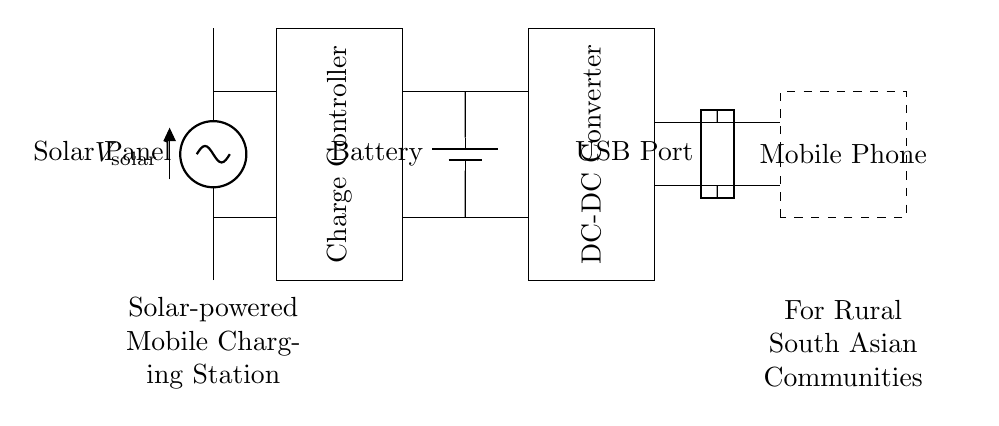What is the component at the top of the diagram? The component at the top is labeled as "Solar Panel," which is the source that converts sunlight into electrical energy.
Answer: Solar Panel What is connected to the charge controller? The charge controller is connected to the solar panel and the battery, managing the flow of energy into the battery to prevent overcharging.
Answer: Solar Panel and Battery What does the DC-DC converter do? The DC-DC converter adjusts the voltage from the battery to a suitable level for charging devices through the USB output.
Answer: Adjusts voltage How many components are involved in the charging process? There are five primary components: the solar panel, charge controller, battery, DC-DC converter, and USB port, all working together for the charging process.
Answer: Five How is the mobile phone connected in the circuit? The mobile phone is connected to the USB port, receiving the output voltage necessary for charging through the wires leading from the DC-DC converter to the USB port.
Answer: USB Port What type of energy source does this circuit utilize? The circuit utilizes solar energy as its primary source, harnessed by the solar panel and converted into electrical energy for charging.
Answer: Solar energy What is the purpose of the battery in this circuit? The purpose of the battery is to store the energy generated by the solar panel, providing a continuous supply when the solar panel may not be producing energy, like during cloudy weather or nighttime.
Answer: Energy storage 